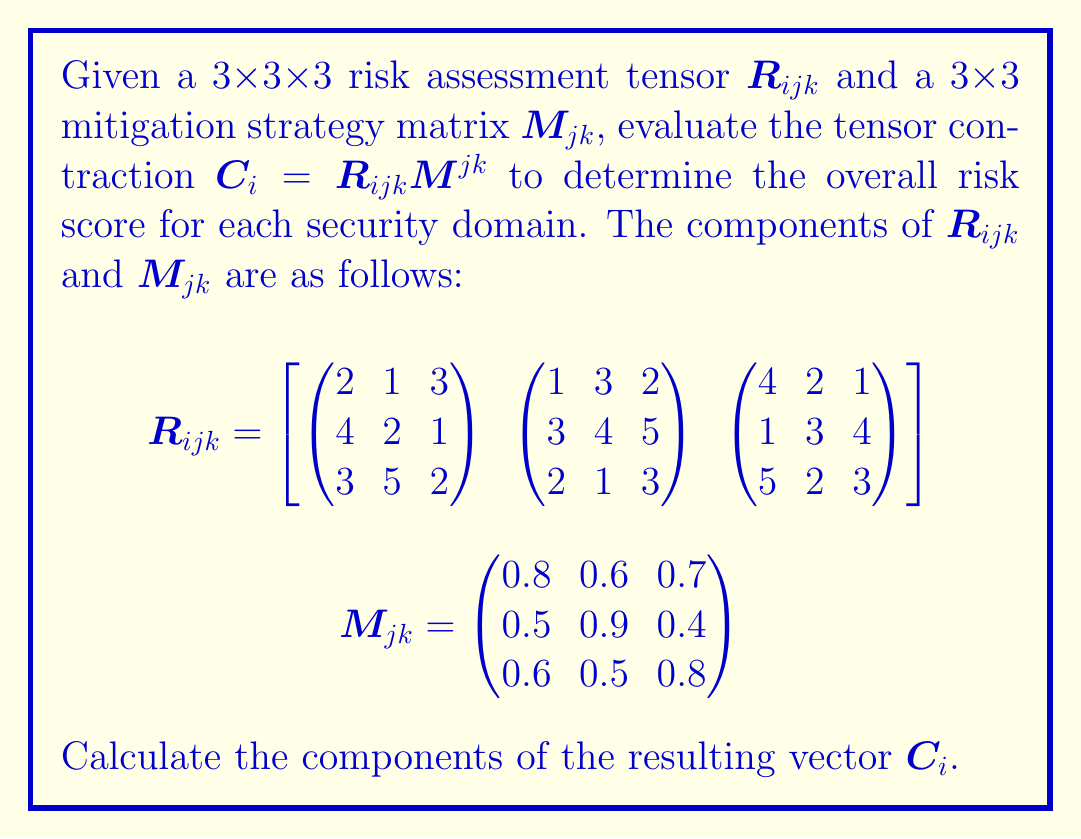What is the answer to this math problem? To evaluate the tensor contraction $C_i = R_{ijk}M^{jk}$, we need to perform the following steps:

1) The tensor contraction is a sum over the repeated indices $j$ and $k$. For each $i$, we calculate:

   $C_i = \sum_{j=1}^3 \sum_{k=1}^3 R_{ijk}M_{jk}$

2) Let's calculate each component of $C_i$ separately:

   For $C_1$:
   $C_1 = (2 \cdot 0.8 + 1 \cdot 0.5 + 3 \cdot 0.6) + (1 \cdot 0.6 + 3 \cdot 0.9 + 2 \cdot 0.5) + (3 \cdot 0.7 + 1 \cdot 0.4 + 2 \cdot 0.8)$
   $C_1 = (1.6 + 0.5 + 1.8) + (0.6 + 2.7 + 1.0) + (2.1 + 0.4 + 1.6)$
   $C_1 = 3.9 + 4.3 + 4.1 = 12.3$

   For $C_2$:
   $C_2 = (4 \cdot 0.8 + 2 \cdot 0.5 + 1 \cdot 0.6) + (3 \cdot 0.6 + 4 \cdot 0.9 + 5 \cdot 0.5) + (1 \cdot 0.7 + 4 \cdot 0.4 + 3 \cdot 0.8)$
   $C_2 = (3.2 + 1.0 + 0.6) + (1.8 + 3.6 + 2.5) + (0.7 + 1.6 + 2.4)$
   $C_2 = 4.8 + 7.9 + 4.7 = 17.4$

   For $C_3$:
   $C_3 = (3 \cdot 0.8 + 5 \cdot 0.5 + 2 \cdot 0.6) + (2 \cdot 0.6 + 1 \cdot 0.9 + 3 \cdot 0.5) + (5 \cdot 0.7 + 2 \cdot 0.4 + 3 \cdot 0.8)$
   $C_3 = (2.4 + 2.5 + 1.2) + (1.2 + 0.9 + 1.5) + (3.5 + 0.8 + 2.4)$
   $C_3 = 6.1 + 3.6 + 6.7 = 16.4$

3) Therefore, the resulting vector $C_i$ is:

   $C_i = \begin{pmatrix} 12.3 \\ 17.4 \\ 16.4 \end{pmatrix}$
Answer: $C_i = (12.3, 17.4, 16.4)$ 